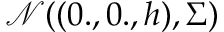<formula> <loc_0><loc_0><loc_500><loc_500>\mathcal { N } ( ( 0 . , 0 . , h ) , \Sigma )</formula> 